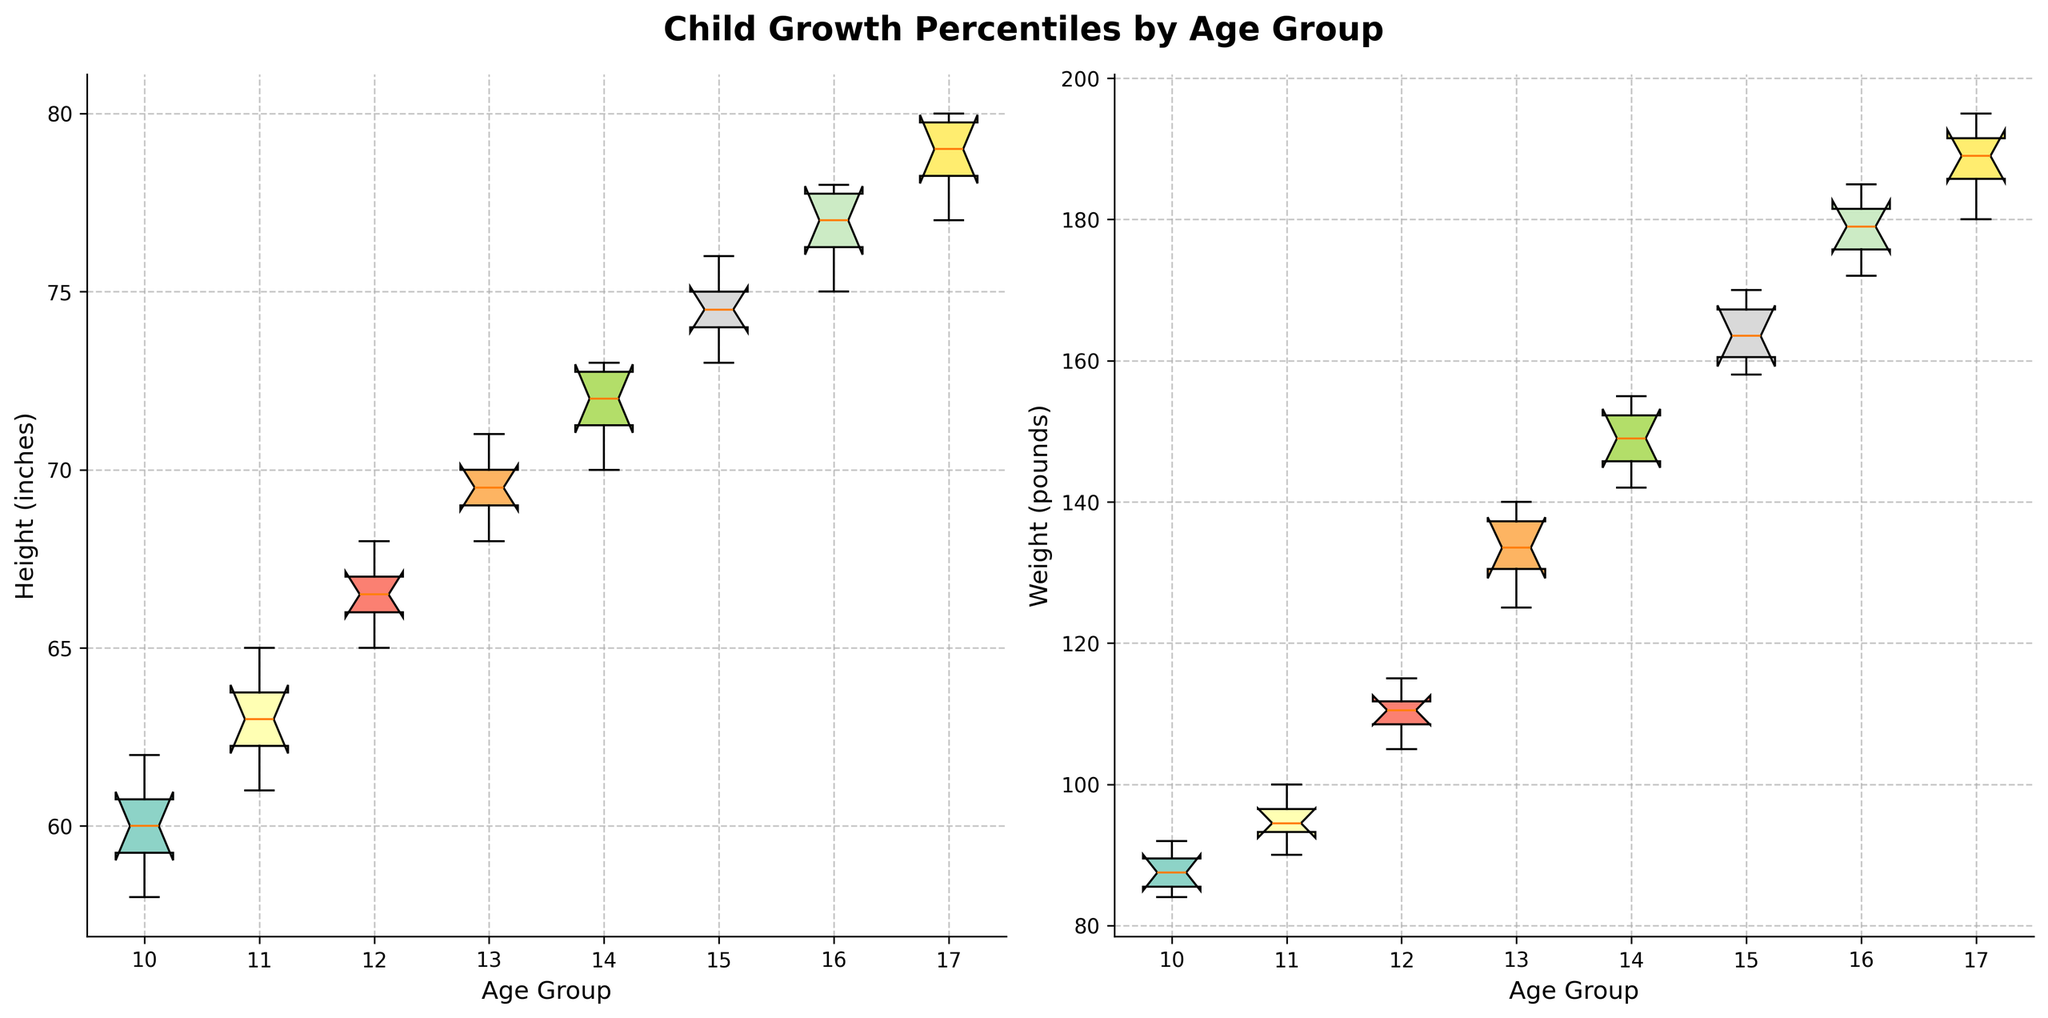How are the heights of children distributed across different age groups? Examine the notched box plot for heights. Each box represents the interquartile range (IQR) with a notch at the median value for each age group. The whiskers extend to the smallest and largest values within 1.5*IQR, and outliers are plotted individually. The boxes show that heights increase as age groups increase from age 10 to 17.
Answer: Heights increase with age groups Which age group has the highest median weight? Look for the notch that is highest on the weight graph. The age group with the highest median weight will have its notch at the highest point vertically. The age group 17 has the highest notch, indicating the highest median weight.
Answer: Age group 17 What's the range of heights for the age group 12? Identify the lower and upper boundaries of the box and whiskers for age group 12 on the height graph. The minimum height is around 65 inches, and the maximum is around 68 inches, giving a range.
Answer: 65-68 inches Which age group shows the greatest variability in weights? Determine variability by the length of the box (IQR) and whiskers. The group with the widest box and longest whiskers has the greatest variability. Age group 13 shows the greatest spread.
Answer: Age group 13 How does the median height change from age 10 to age 17? Observe the notches (median values) in the height graph from age 10 to 17. Note the upward trend where the notch moves higher as age increases.
Answer: Increases Which age group shows the least overlap in height compared to other age groups? Compare the notches and spread of each box plot for heights. The less overlap indicates distinct growth patterns. Age group 17 has the least overlap with other age groups.
Answer: Age group 17 What is the interquartile range (IQR) of weights for age group 14? Locate the bottom and top of the box for age group 14 on the weight graph, representing Q1 and Q3. Subtract Q1 from Q3 to find IQR. Q1 is around 145 pounds, and Q3 is around 153 pounds, giving an IQR of 8 pounds.
Answer: 8 pounds Are there any age groups with outliers in height? Look for points outside the whiskers on the height graph. Age group 10 has outliers below the whiskers.
Answer: Age group 10 How does the spread of weights for age group 16 compare to that of age group 15? Compare the length of the boxes and whiskers for these age groups on the weight graph. Age group 16 has a longer range, indicating more spread.
Answer: Age group 16 has more spread 